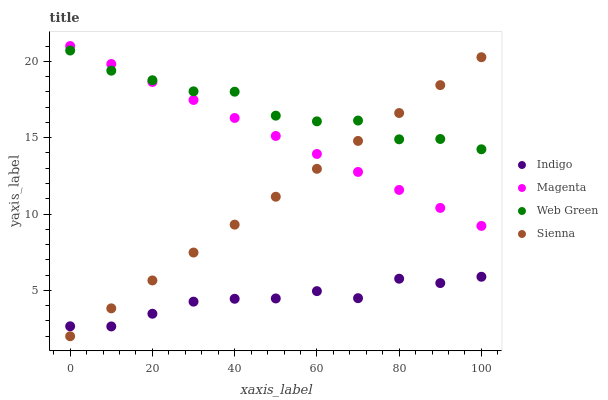Does Indigo have the minimum area under the curve?
Answer yes or no. Yes. Does Web Green have the maximum area under the curve?
Answer yes or no. Yes. Does Magenta have the minimum area under the curve?
Answer yes or no. No. Does Magenta have the maximum area under the curve?
Answer yes or no. No. Is Sienna the smoothest?
Answer yes or no. Yes. Is Web Green the roughest?
Answer yes or no. Yes. Is Magenta the smoothest?
Answer yes or no. No. Is Magenta the roughest?
Answer yes or no. No. Does Sienna have the lowest value?
Answer yes or no. Yes. Does Magenta have the lowest value?
Answer yes or no. No. Does Magenta have the highest value?
Answer yes or no. Yes. Does Indigo have the highest value?
Answer yes or no. No. Is Indigo less than Magenta?
Answer yes or no. Yes. Is Web Green greater than Indigo?
Answer yes or no. Yes. Does Indigo intersect Sienna?
Answer yes or no. Yes. Is Indigo less than Sienna?
Answer yes or no. No. Is Indigo greater than Sienna?
Answer yes or no. No. Does Indigo intersect Magenta?
Answer yes or no. No. 